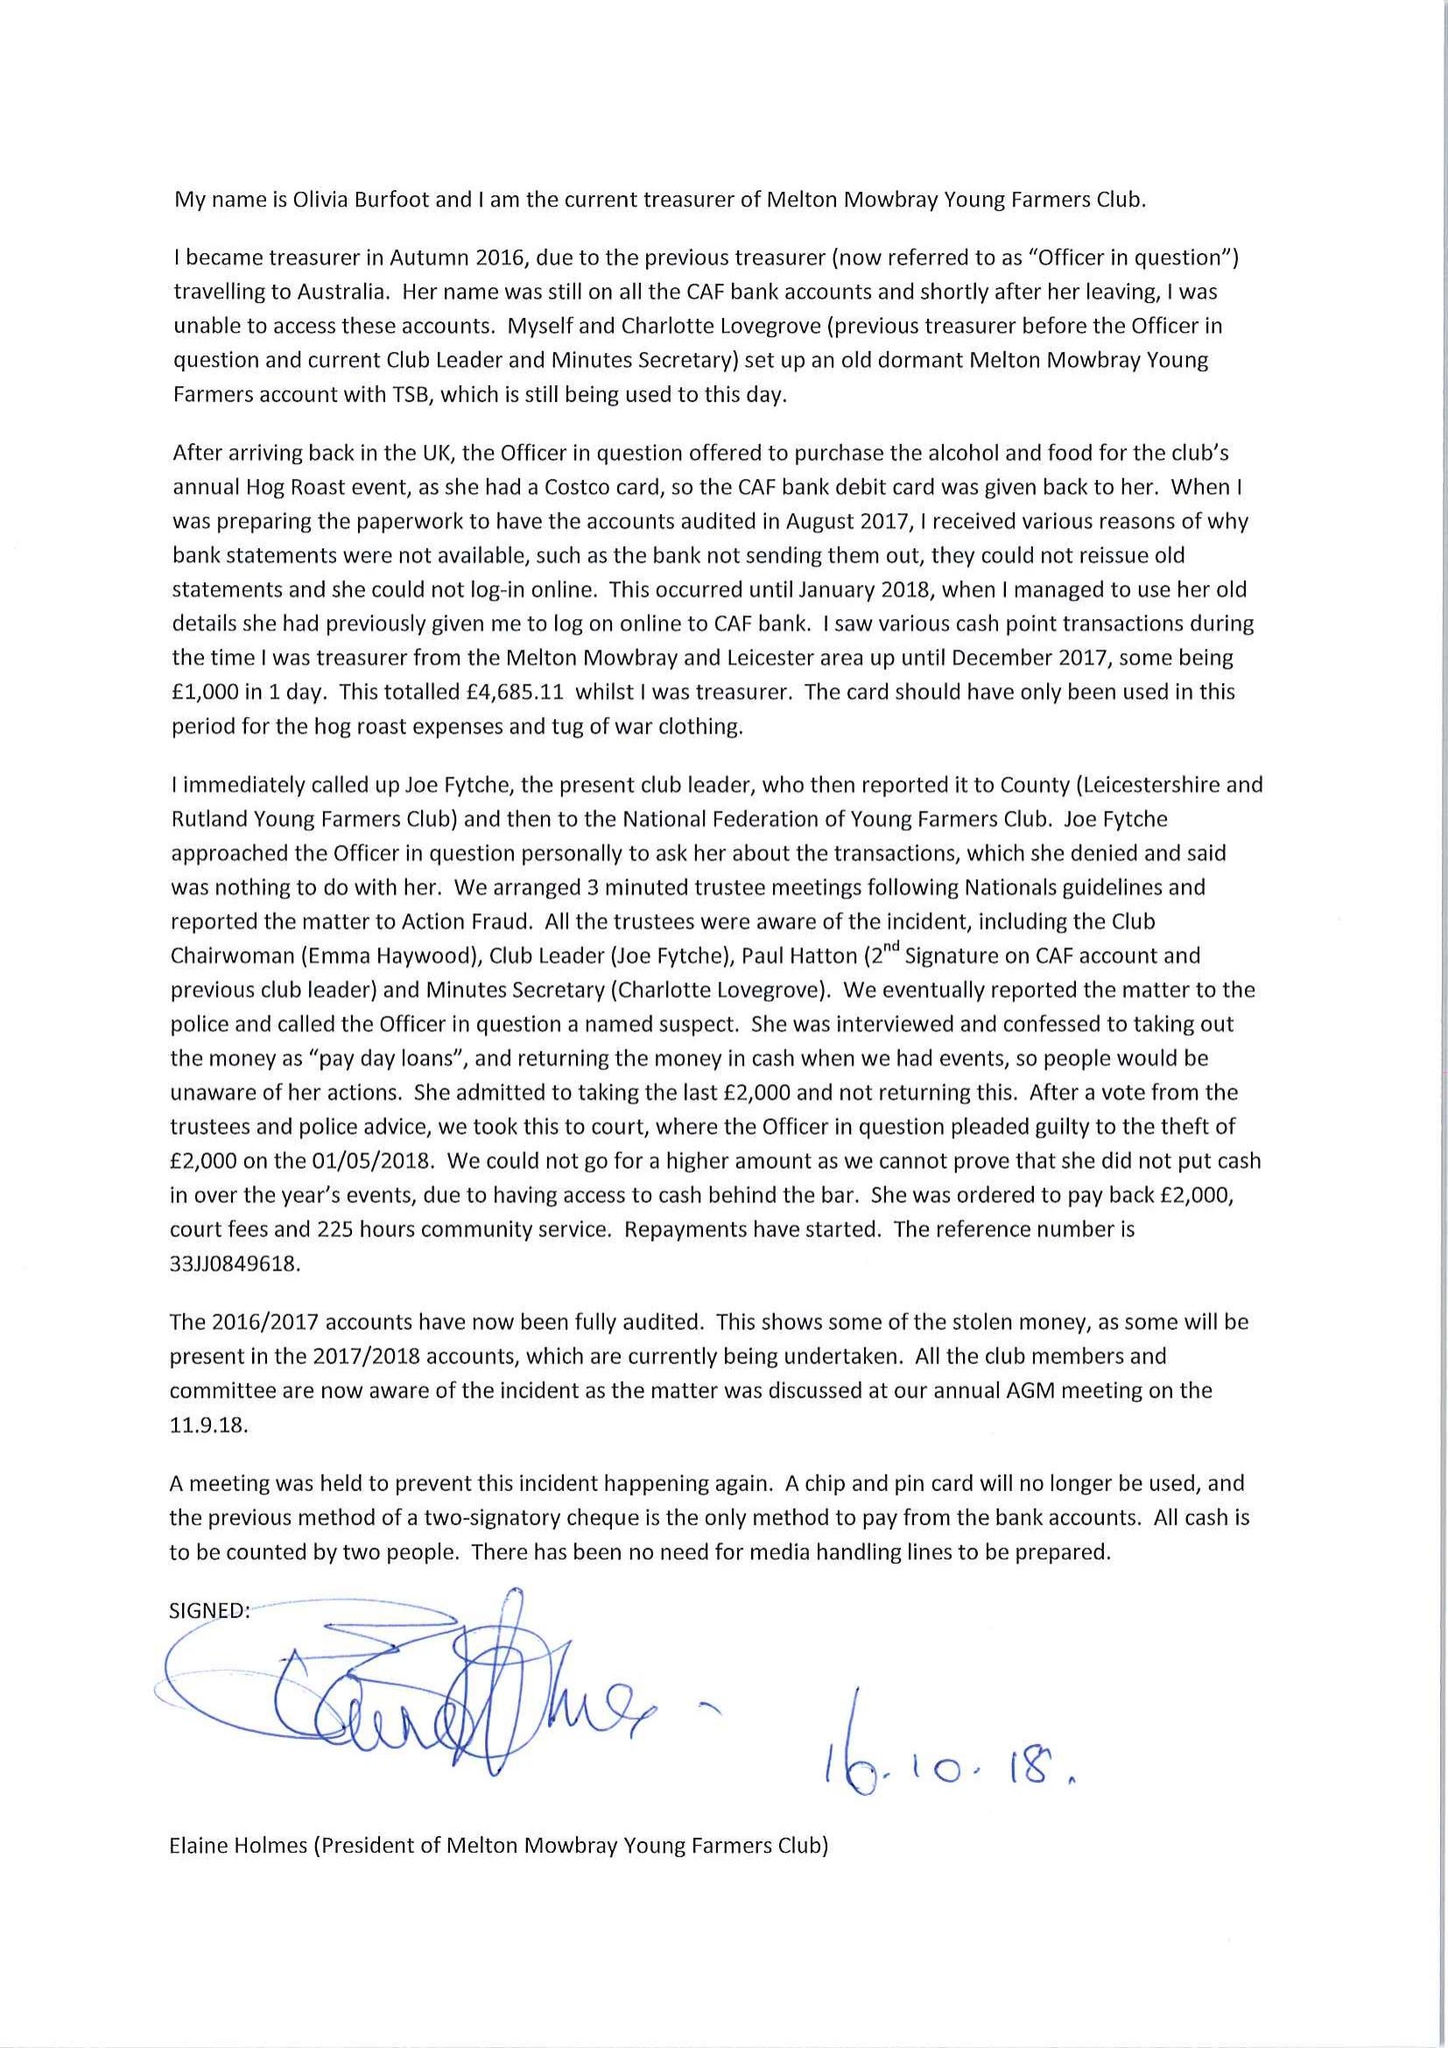What is the value for the spending_annually_in_british_pounds?
Answer the question using a single word or phrase. 26248.00 